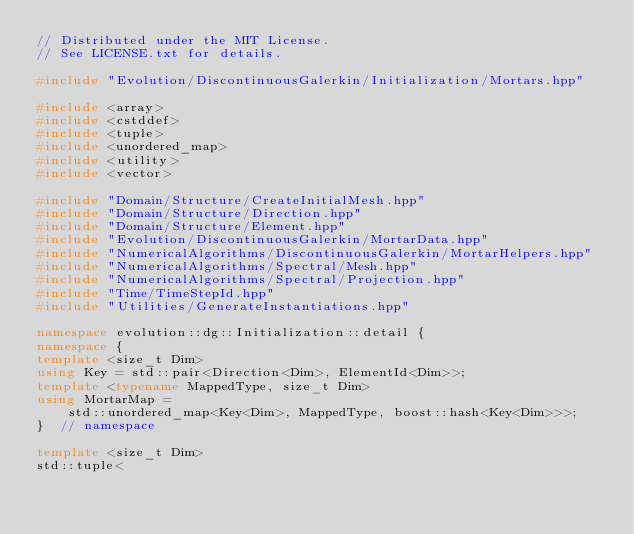<code> <loc_0><loc_0><loc_500><loc_500><_C++_>// Distributed under the MIT License.
// See LICENSE.txt for details.

#include "Evolution/DiscontinuousGalerkin/Initialization/Mortars.hpp"

#include <array>
#include <cstddef>
#include <tuple>
#include <unordered_map>
#include <utility>
#include <vector>

#include "Domain/Structure/CreateInitialMesh.hpp"
#include "Domain/Structure/Direction.hpp"
#include "Domain/Structure/Element.hpp"
#include "Evolution/DiscontinuousGalerkin/MortarData.hpp"
#include "NumericalAlgorithms/DiscontinuousGalerkin/MortarHelpers.hpp"
#include "NumericalAlgorithms/Spectral/Mesh.hpp"
#include "NumericalAlgorithms/Spectral/Projection.hpp"
#include "Time/TimeStepId.hpp"
#include "Utilities/GenerateInstantiations.hpp"

namespace evolution::dg::Initialization::detail {
namespace {
template <size_t Dim>
using Key = std::pair<Direction<Dim>, ElementId<Dim>>;
template <typename MappedType, size_t Dim>
using MortarMap =
    std::unordered_map<Key<Dim>, MappedType, boost::hash<Key<Dim>>>;
}  // namespace

template <size_t Dim>
std::tuple<</code> 